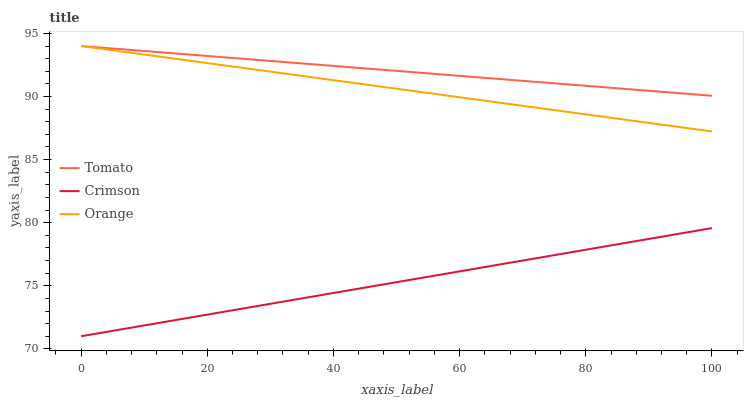Does Crimson have the minimum area under the curve?
Answer yes or no. Yes. Does Tomato have the maximum area under the curve?
Answer yes or no. Yes. Does Orange have the minimum area under the curve?
Answer yes or no. No. Does Orange have the maximum area under the curve?
Answer yes or no. No. Is Crimson the smoothest?
Answer yes or no. Yes. Is Tomato the roughest?
Answer yes or no. Yes. Is Orange the smoothest?
Answer yes or no. No. Is Orange the roughest?
Answer yes or no. No. Does Crimson have the lowest value?
Answer yes or no. Yes. Does Orange have the lowest value?
Answer yes or no. No. Does Orange have the highest value?
Answer yes or no. Yes. Does Crimson have the highest value?
Answer yes or no. No. Is Crimson less than Orange?
Answer yes or no. Yes. Is Orange greater than Crimson?
Answer yes or no. Yes. Does Orange intersect Tomato?
Answer yes or no. Yes. Is Orange less than Tomato?
Answer yes or no. No. Is Orange greater than Tomato?
Answer yes or no. No. Does Crimson intersect Orange?
Answer yes or no. No. 